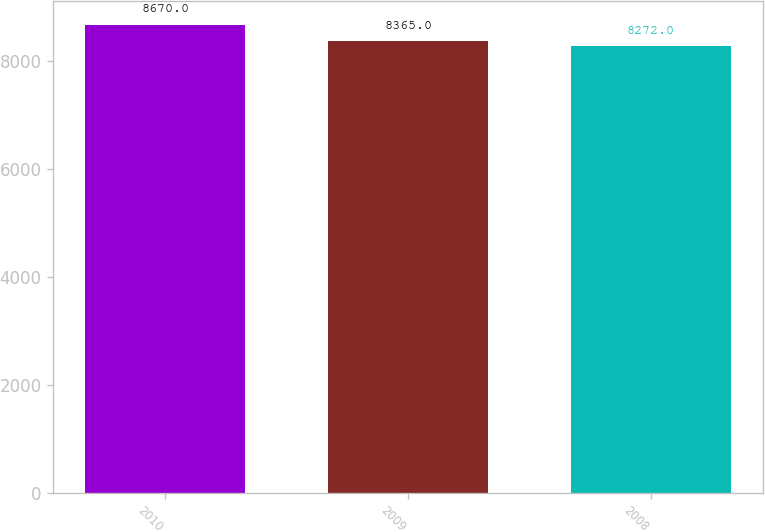<chart> <loc_0><loc_0><loc_500><loc_500><bar_chart><fcel>2010<fcel>2009<fcel>2008<nl><fcel>8670<fcel>8365<fcel>8272<nl></chart> 